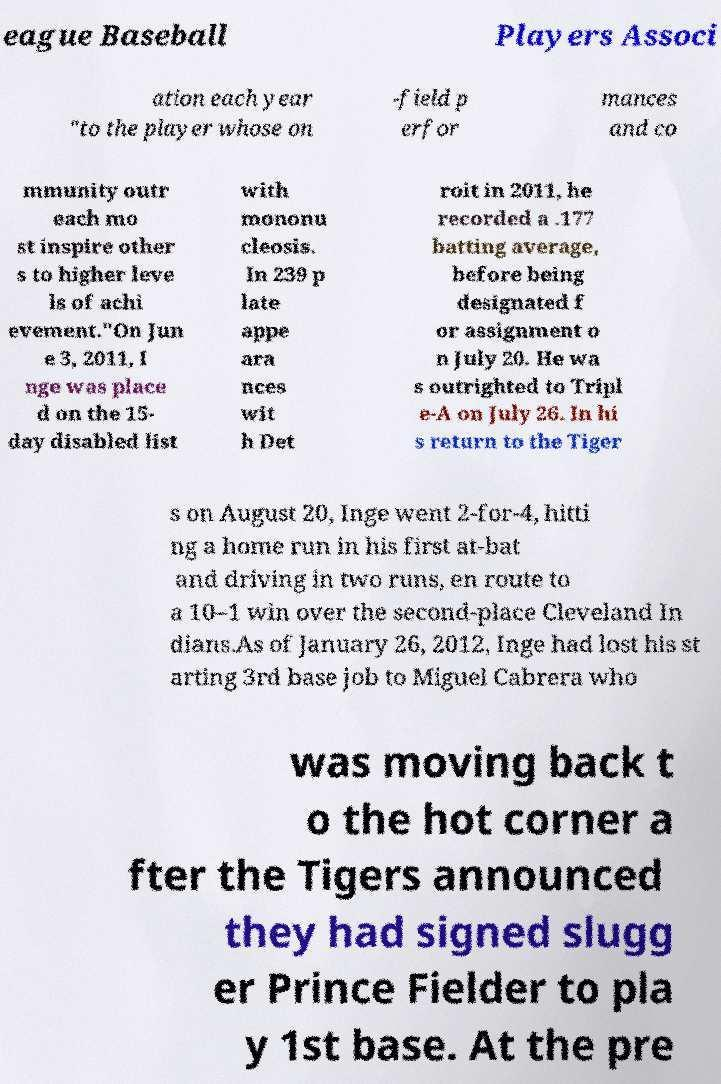Can you accurately transcribe the text from the provided image for me? eague Baseball Players Associ ation each year "to the player whose on -field p erfor mances and co mmunity outr each mo st inspire other s to higher leve ls of achi evement."On Jun e 3, 2011, I nge was place d on the 15- day disabled list with mononu cleosis. In 239 p late appe ara nces wit h Det roit in 2011, he recorded a .177 batting average, before being designated f or assignment o n July 20. He wa s outrighted to Tripl e-A on July 26. In hi s return to the Tiger s on August 20, Inge went 2-for-4, hitti ng a home run in his first at-bat and driving in two runs, en route to a 10–1 win over the second-place Cleveland In dians.As of January 26, 2012, Inge had lost his st arting 3rd base job to Miguel Cabrera who was moving back t o the hot corner a fter the Tigers announced they had signed slugg er Prince Fielder to pla y 1st base. At the pre 